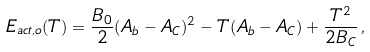Convert formula to latex. <formula><loc_0><loc_0><loc_500><loc_500>E _ { a c t , o } ( T ) = \frac { B _ { 0 } } { 2 } ( A _ { b } - A _ { C } ) ^ { 2 } - T ( A _ { b } - A _ { C } ) + \frac { T ^ { 2 } } { 2 B _ { C } } \, ,</formula> 